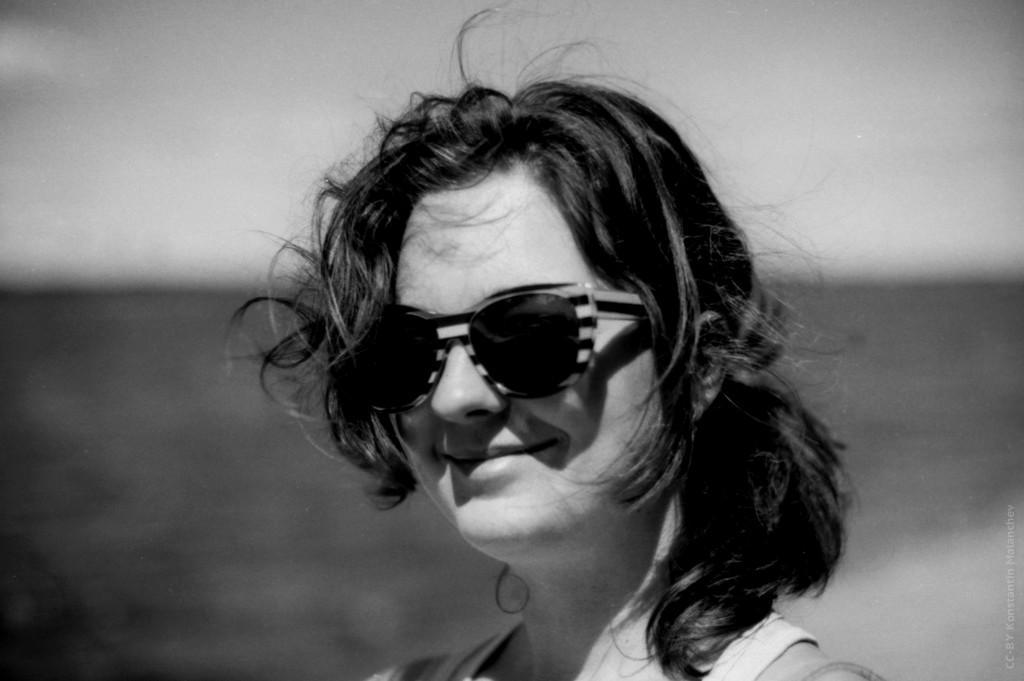Please provide a concise description of this image. In this image we can see a lady smiling. She is wearing glasses. 